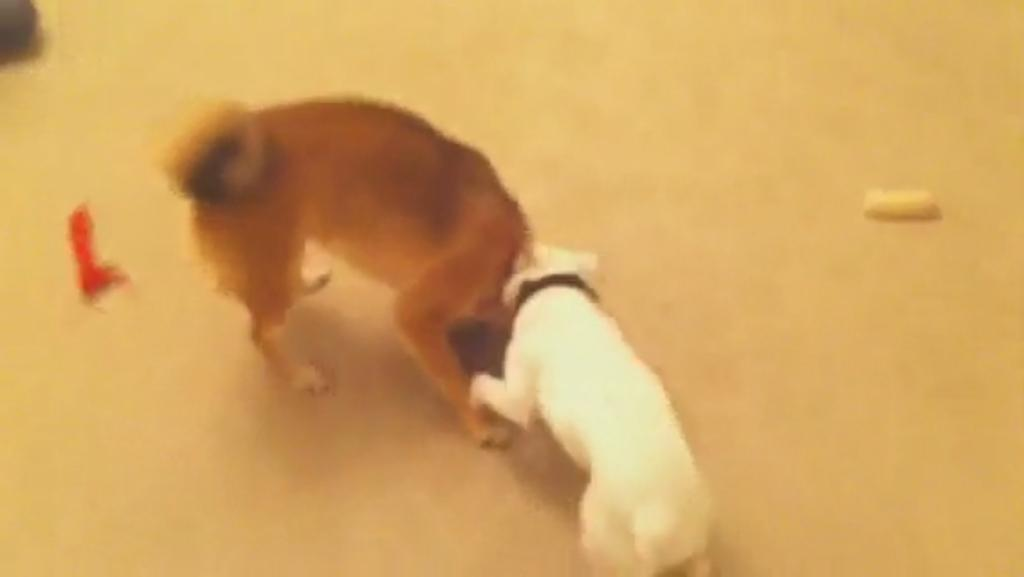Where was the image most likely taken? The image was likely taken outside. What can be seen in the center of the image? There are two animals standing in the center of the image. What is the surface on which the animals are standing? The animals are standing on the ground. What else can be seen on the ground in the image? There are objects placed on the ground in the image. What type of destruction can be seen in the image? There is no destruction present in the image; it features two animals standing on the ground with objects placed nearby. What type of bulb is being used to light up the scene in the image? There is no bulb present in the image; it was likely taken during daylight hours outside. 